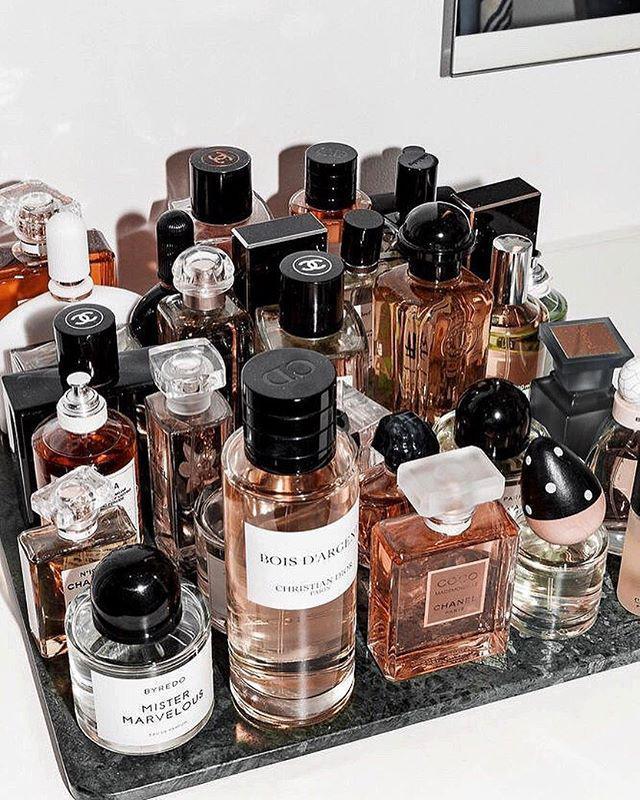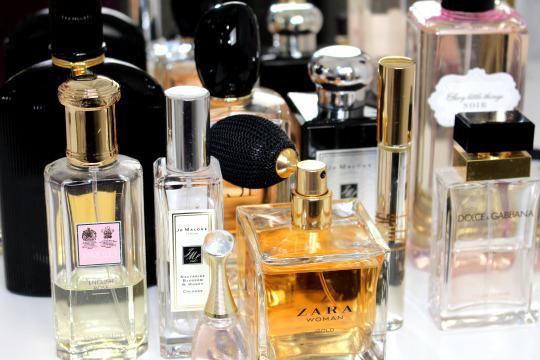The first image is the image on the left, the second image is the image on the right. Considering the images on both sides, is "In at least one image there are five different perfume bottles in a row." valid? Answer yes or no. Yes. The first image is the image on the left, the second image is the image on the right. Considering the images on both sides, is "The left image shows a collection of fragrance bottles on a tray, and the leftmost bottle in the front row has a round black cap." valid? Answer yes or no. Yes. 